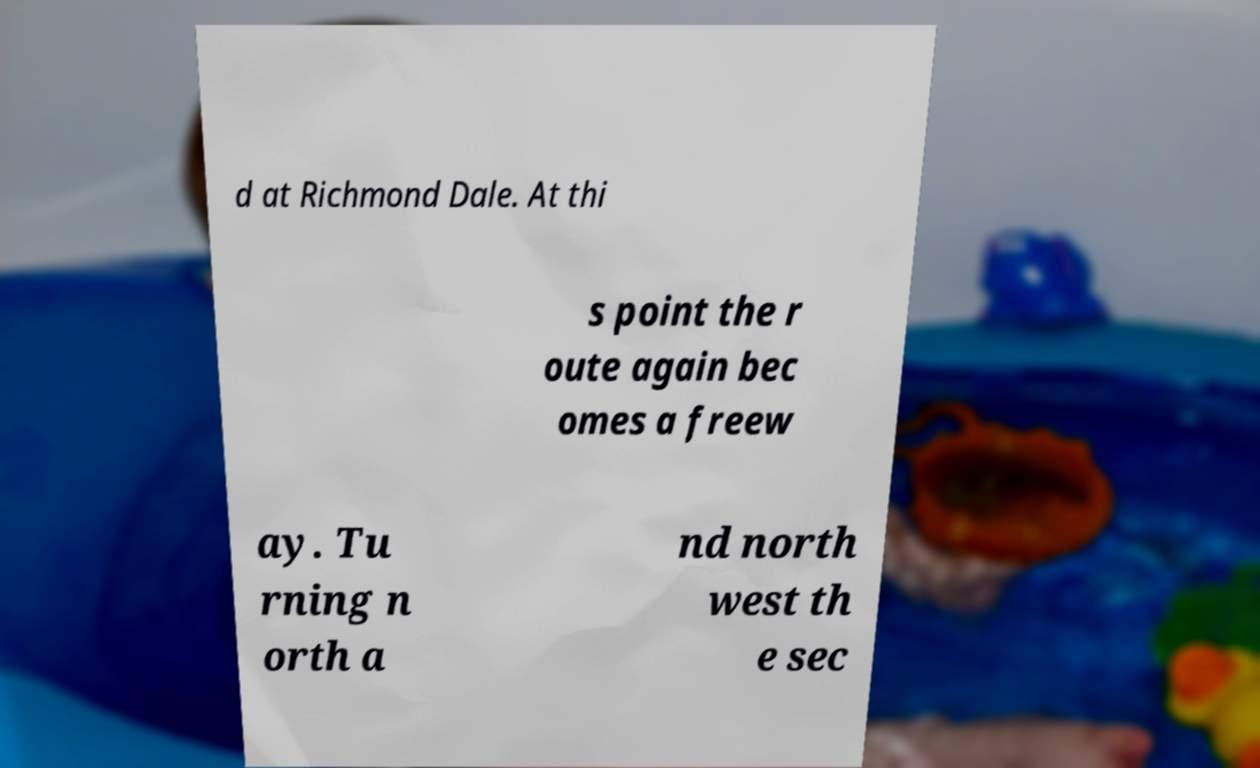Could you assist in decoding the text presented in this image and type it out clearly? d at Richmond Dale. At thi s point the r oute again bec omes a freew ay. Tu rning n orth a nd north west th e sec 